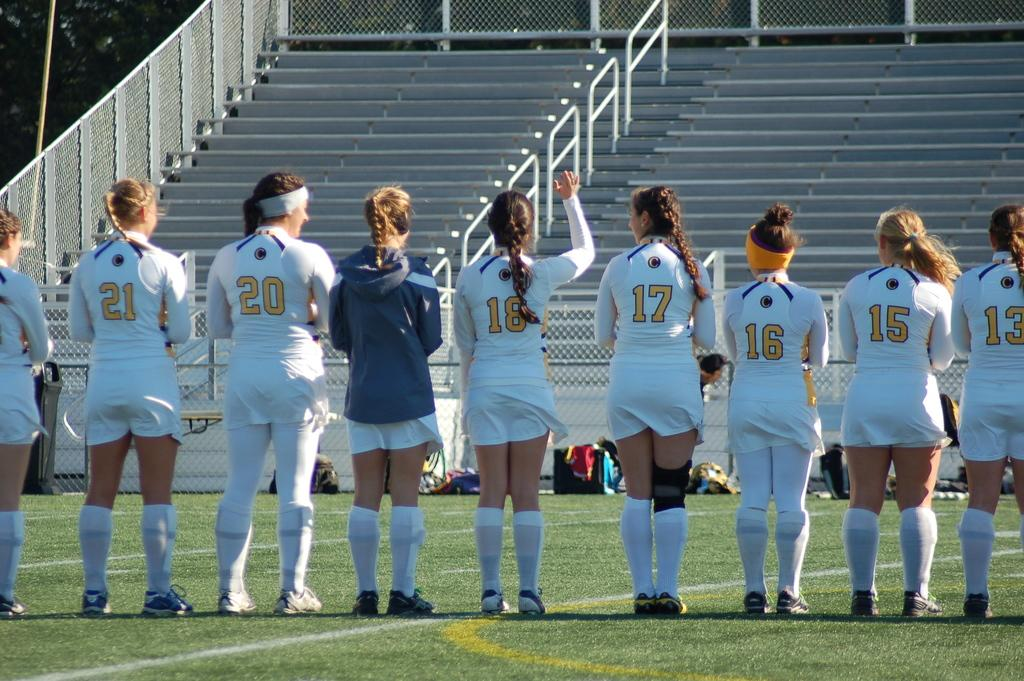<image>
Give a short and clear explanation of the subsequent image. Several female athletes are standing shoulder to shoulder with one having the number 17 on her back. 